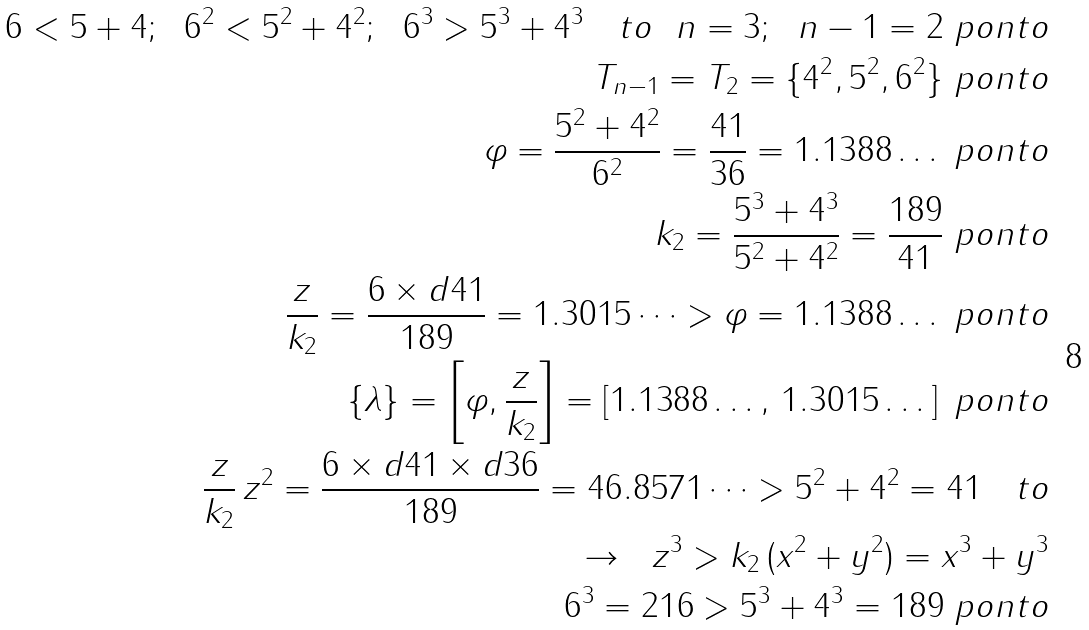Convert formula to latex. <formula><loc_0><loc_0><loc_500><loc_500>6 < 5 + 4 ; \ \ 6 ^ { 2 } < 5 ^ { 2 } + 4 ^ { 2 } ; \ \ 6 ^ { 3 } > 5 ^ { 3 } + 4 ^ { 3 } \quad t o \ \ n = 3 ; \ \ n - 1 = 2 \ p o n t o \\ T _ { n - 1 } = T _ { 2 } = \{ 4 ^ { 2 } , 5 ^ { 2 } , 6 ^ { 2 } \} \ p o n t o \\ \varphi = \frac { 5 ^ { 2 } + 4 ^ { 2 } } { 6 ^ { 2 } } = \frac { 4 1 } { 3 6 } = 1 . 1 3 8 8 \dots \ p o n t o \\ k _ { 2 } = \frac { 5 ^ { 3 } + 4 ^ { 3 } } { 5 ^ { 2 } + 4 ^ { 2 } } = \frac { 1 8 9 } { 4 1 } \ p o n t o \\ \frac { z } { k _ { 2 } } = \frac { 6 \times d 4 1 } { 1 8 9 } = 1 . 3 0 1 5 \dots > \varphi = 1 . 1 3 8 8 \dots \ p o n t o \\ \{ \lambda \} = \left [ \varphi , \frac { z } { k _ { 2 } } \right ] = \left [ 1 . 1 3 8 8 \dots , \, 1 . 3 0 1 5 \dots \right ] \ p o n t o \\ \frac { z } { k _ { 2 } } \, z ^ { 2 } = \frac { 6 \times d 4 1 \times d 3 6 } { 1 8 9 } = 4 6 . 8 5 7 1 \dots > 5 ^ { 2 } + 4 ^ { 2 } = 4 1 \quad t o \\ \to \ \ z ^ { 3 } > k _ { 2 } \, ( x ^ { 2 } + y ^ { 2 } ) = x ^ { 3 } + y ^ { 3 } \\ 6 ^ { 3 } = 2 1 6 > 5 ^ { 3 } + 4 ^ { 3 } = 1 8 9 \ p o n t o</formula> 